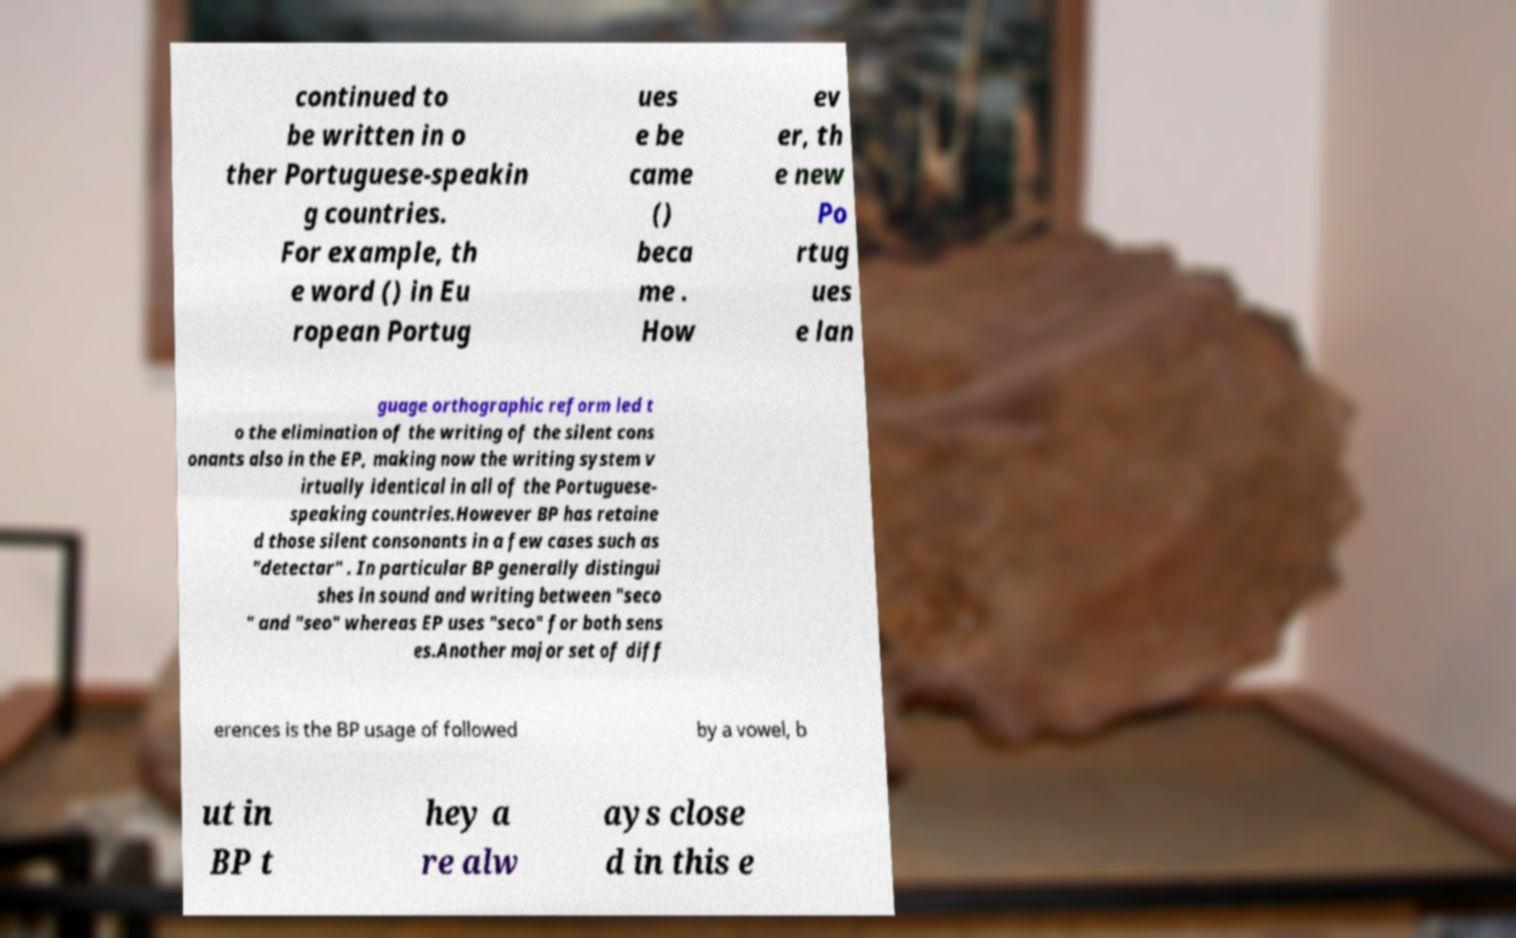Please read and relay the text visible in this image. What does it say? continued to be written in o ther Portuguese-speakin g countries. For example, th e word () in Eu ropean Portug ues e be came () beca me . How ev er, th e new Po rtug ues e lan guage orthographic reform led t o the elimination of the writing of the silent cons onants also in the EP, making now the writing system v irtually identical in all of the Portuguese- speaking countries.However BP has retaine d those silent consonants in a few cases such as "detectar" . In particular BP generally distingui shes in sound and writing between "seco " and "seo" whereas EP uses "seco" for both sens es.Another major set of diff erences is the BP usage of followed by a vowel, b ut in BP t hey a re alw ays close d in this e 